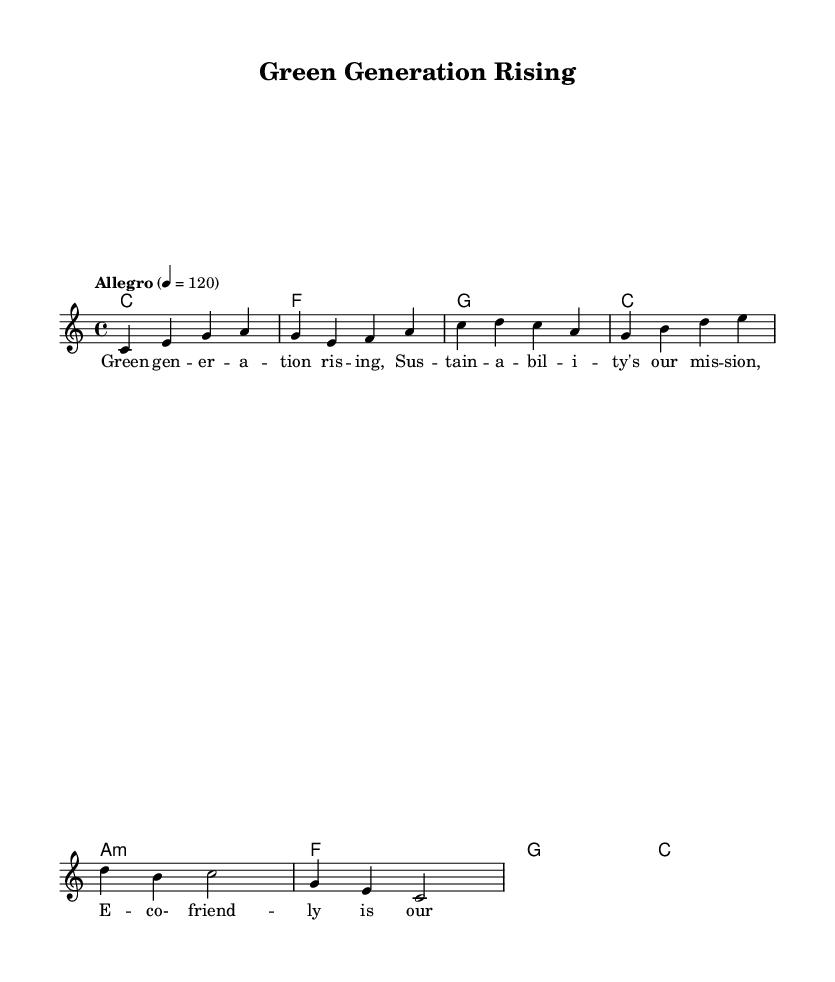What is the key signature of this music? The key signature is indicated at the beginning of the staff, showing C major, which has no sharps or flats.
Answer: C major What is the time signature of this music? The time signature, found at the start of the score, is 4/4, indicating four beats per measure.
Answer: 4/4 What is the tempo marking for this piece? The tempo marking "Allegro" and the metronome marking of 120 indicates a fast and lively pace for the music.
Answer: Allegro How many measures are in the melody section? By counting the individual segments of the melody, we determine that it consists of 4 measures in total.
Answer: 4 measures What type of chord is the second chord in the harmony section? The second chord is an F major chord, identifiable as the first chord following the tonic C major chord.
Answer: F major Which lyric line corresponds to the first measure of melody? The first measure of melody aligns with the lyric line "Green generation rising," marking the start of the song.
Answer: Green generation rising What is the rhythmic pattern in the melody of the first measure? The first measure consists of four quarter notes (c, e, g, a), creating a straightforward rhythmic pattern aligned with the 4/4 time signature.
Answer: Four quarter notes 